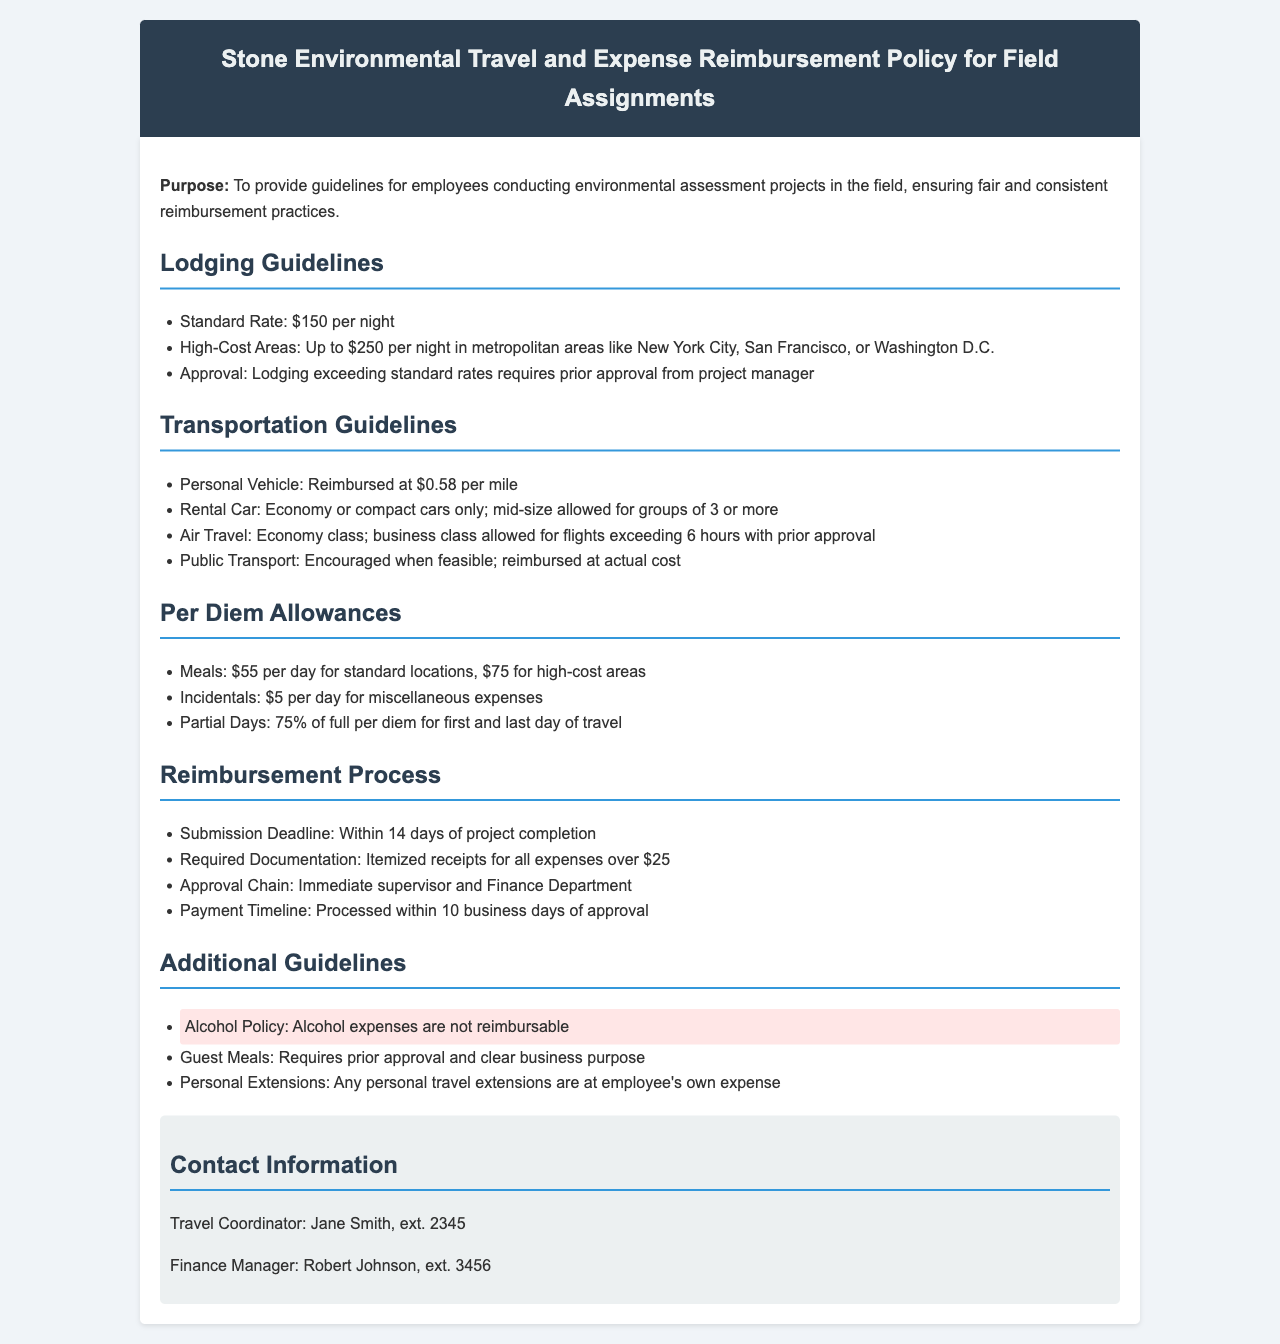What is the standard lodging rate? The standard lodging rate for field assignments is specified in the guidelines as $150 per night.
Answer: $150 per night What should be done if lodging exceeds the standard rate? The document states that lodging exceeding standard rates requires prior approval from the project manager.
Answer: Prior approval from project manager What is the reimbursement rate for personal vehicle mileage? The reimbursement rate for personal vehicle mileage is outlined as $0.58 per mile.
Answer: $0.58 per mile What is the per diem allowance for meals in high-cost areas? The per diem allowance for meals in high-cost areas is indicated as $75 per day.
Answer: $75 per day What is the deadline for submitting reimbursement requests? The submission deadline for reimbursement requests is clearly stated as within 14 days of project completion.
Answer: Within 14 days Which expenses are not reimbursable according to the policy? The document highlights that alcohol expenses are not reimbursable according to the additional guidelines.
Answer: Alcohol expenses How long does it take to process a reimbursement after approval? The payment timeline for processing a reimbursement is mentioned to be within 10 business days of approval.
Answer: Within 10 business days What types of vehicles are allowed for rental reimbursement? The transportation guidelines specify that only economy or compact cars are allowed for rental reimbursement.
Answer: Economy or compact cars What should be included with reimbursement submissions over $25? The required documentation for reimbursement submissions over $25 must include itemized receipts, as stated in the reimbursement process section.
Answer: Itemized receipts What is required for guest meals reimbursement? The document specifies that guest meals require prior approval and a clear business purpose for reimbursement.
Answer: Prior approval and clear business purpose 